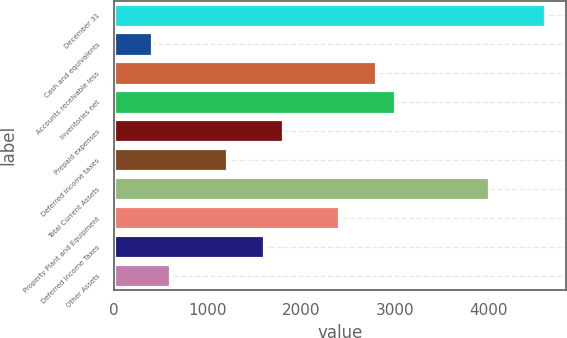<chart> <loc_0><loc_0><loc_500><loc_500><bar_chart><fcel>December 31<fcel>Cash and equivalents<fcel>Accounts receivable less<fcel>Inventories net<fcel>Prepaid expenses<fcel>Deferred income taxes<fcel>Total Current Assets<fcel>Property Plant and Equipment<fcel>Deferred Income Taxes<fcel>Other Assets<nl><fcel>4602<fcel>402<fcel>2802<fcel>3002<fcel>1802<fcel>1202<fcel>4002<fcel>2402<fcel>1602<fcel>602<nl></chart> 